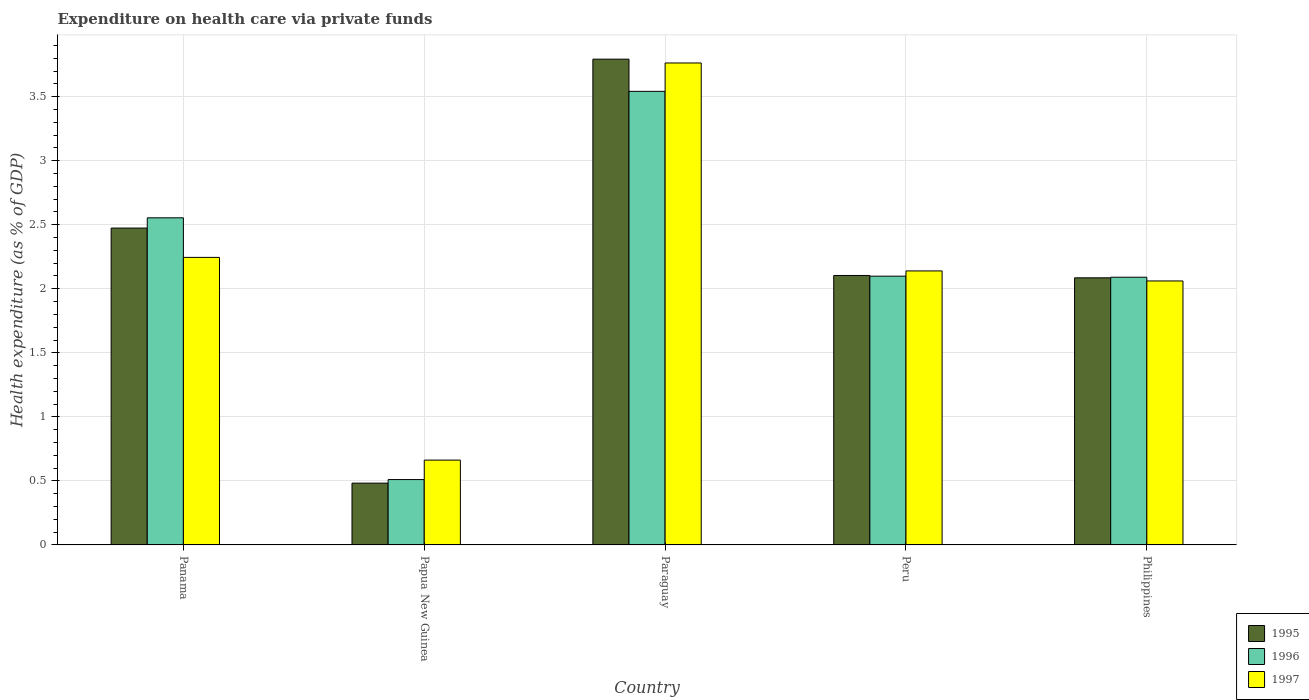How many different coloured bars are there?
Keep it short and to the point. 3. Are the number of bars per tick equal to the number of legend labels?
Offer a terse response. Yes. In how many cases, is the number of bars for a given country not equal to the number of legend labels?
Give a very brief answer. 0. What is the expenditure made on health care in 1996 in Paraguay?
Your answer should be very brief. 3.54. Across all countries, what is the maximum expenditure made on health care in 1996?
Offer a terse response. 3.54. Across all countries, what is the minimum expenditure made on health care in 1996?
Your answer should be compact. 0.51. In which country was the expenditure made on health care in 1996 maximum?
Your response must be concise. Paraguay. In which country was the expenditure made on health care in 1995 minimum?
Offer a very short reply. Papua New Guinea. What is the total expenditure made on health care in 1996 in the graph?
Your answer should be compact. 10.8. What is the difference between the expenditure made on health care in 1996 in Paraguay and that in Peru?
Your answer should be very brief. 1.44. What is the difference between the expenditure made on health care in 1997 in Peru and the expenditure made on health care in 1995 in Panama?
Your answer should be very brief. -0.33. What is the average expenditure made on health care in 1996 per country?
Provide a short and direct response. 2.16. What is the difference between the expenditure made on health care of/in 1996 and expenditure made on health care of/in 1995 in Paraguay?
Provide a short and direct response. -0.25. In how many countries, is the expenditure made on health care in 1996 greater than 3.6 %?
Offer a terse response. 0. What is the ratio of the expenditure made on health care in 1997 in Paraguay to that in Philippines?
Your answer should be compact. 1.83. Is the expenditure made on health care in 1997 in Paraguay less than that in Philippines?
Offer a terse response. No. What is the difference between the highest and the second highest expenditure made on health care in 1996?
Give a very brief answer. -0.99. What is the difference between the highest and the lowest expenditure made on health care in 1996?
Ensure brevity in your answer.  3.03. In how many countries, is the expenditure made on health care in 1997 greater than the average expenditure made on health care in 1997 taken over all countries?
Provide a succinct answer. 2. What does the 3rd bar from the right in Paraguay represents?
Offer a terse response. 1995. How many bars are there?
Keep it short and to the point. 15. How many countries are there in the graph?
Offer a terse response. 5. Does the graph contain grids?
Provide a succinct answer. Yes. How many legend labels are there?
Keep it short and to the point. 3. How are the legend labels stacked?
Make the answer very short. Vertical. What is the title of the graph?
Provide a succinct answer. Expenditure on health care via private funds. What is the label or title of the X-axis?
Your answer should be very brief. Country. What is the label or title of the Y-axis?
Ensure brevity in your answer.  Health expenditure (as % of GDP). What is the Health expenditure (as % of GDP) of 1995 in Panama?
Keep it short and to the point. 2.47. What is the Health expenditure (as % of GDP) in 1996 in Panama?
Your answer should be very brief. 2.55. What is the Health expenditure (as % of GDP) in 1997 in Panama?
Give a very brief answer. 2.25. What is the Health expenditure (as % of GDP) of 1995 in Papua New Guinea?
Your answer should be compact. 0.48. What is the Health expenditure (as % of GDP) of 1996 in Papua New Guinea?
Give a very brief answer. 0.51. What is the Health expenditure (as % of GDP) in 1997 in Papua New Guinea?
Your response must be concise. 0.66. What is the Health expenditure (as % of GDP) in 1995 in Paraguay?
Your answer should be very brief. 3.79. What is the Health expenditure (as % of GDP) of 1996 in Paraguay?
Offer a very short reply. 3.54. What is the Health expenditure (as % of GDP) of 1997 in Paraguay?
Offer a very short reply. 3.76. What is the Health expenditure (as % of GDP) of 1995 in Peru?
Keep it short and to the point. 2.1. What is the Health expenditure (as % of GDP) of 1996 in Peru?
Your answer should be very brief. 2.1. What is the Health expenditure (as % of GDP) of 1997 in Peru?
Offer a terse response. 2.14. What is the Health expenditure (as % of GDP) of 1995 in Philippines?
Your answer should be compact. 2.09. What is the Health expenditure (as % of GDP) in 1996 in Philippines?
Provide a short and direct response. 2.09. What is the Health expenditure (as % of GDP) in 1997 in Philippines?
Offer a terse response. 2.06. Across all countries, what is the maximum Health expenditure (as % of GDP) in 1995?
Your answer should be very brief. 3.79. Across all countries, what is the maximum Health expenditure (as % of GDP) in 1996?
Your answer should be very brief. 3.54. Across all countries, what is the maximum Health expenditure (as % of GDP) of 1997?
Offer a very short reply. 3.76. Across all countries, what is the minimum Health expenditure (as % of GDP) in 1995?
Provide a succinct answer. 0.48. Across all countries, what is the minimum Health expenditure (as % of GDP) in 1996?
Keep it short and to the point. 0.51. Across all countries, what is the minimum Health expenditure (as % of GDP) of 1997?
Offer a terse response. 0.66. What is the total Health expenditure (as % of GDP) in 1995 in the graph?
Provide a succinct answer. 10.94. What is the total Health expenditure (as % of GDP) in 1996 in the graph?
Offer a terse response. 10.8. What is the total Health expenditure (as % of GDP) in 1997 in the graph?
Provide a succinct answer. 10.87. What is the difference between the Health expenditure (as % of GDP) in 1995 in Panama and that in Papua New Guinea?
Ensure brevity in your answer.  1.99. What is the difference between the Health expenditure (as % of GDP) of 1996 in Panama and that in Papua New Guinea?
Provide a short and direct response. 2.04. What is the difference between the Health expenditure (as % of GDP) of 1997 in Panama and that in Papua New Guinea?
Offer a terse response. 1.58. What is the difference between the Health expenditure (as % of GDP) of 1995 in Panama and that in Paraguay?
Make the answer very short. -1.32. What is the difference between the Health expenditure (as % of GDP) of 1996 in Panama and that in Paraguay?
Keep it short and to the point. -0.99. What is the difference between the Health expenditure (as % of GDP) of 1997 in Panama and that in Paraguay?
Make the answer very short. -1.52. What is the difference between the Health expenditure (as % of GDP) of 1995 in Panama and that in Peru?
Provide a succinct answer. 0.37. What is the difference between the Health expenditure (as % of GDP) in 1996 in Panama and that in Peru?
Ensure brevity in your answer.  0.46. What is the difference between the Health expenditure (as % of GDP) in 1997 in Panama and that in Peru?
Ensure brevity in your answer.  0.11. What is the difference between the Health expenditure (as % of GDP) of 1995 in Panama and that in Philippines?
Provide a short and direct response. 0.39. What is the difference between the Health expenditure (as % of GDP) in 1996 in Panama and that in Philippines?
Offer a terse response. 0.46. What is the difference between the Health expenditure (as % of GDP) of 1997 in Panama and that in Philippines?
Offer a very short reply. 0.18. What is the difference between the Health expenditure (as % of GDP) of 1995 in Papua New Guinea and that in Paraguay?
Offer a terse response. -3.31. What is the difference between the Health expenditure (as % of GDP) of 1996 in Papua New Guinea and that in Paraguay?
Ensure brevity in your answer.  -3.03. What is the difference between the Health expenditure (as % of GDP) in 1997 in Papua New Guinea and that in Paraguay?
Keep it short and to the point. -3.1. What is the difference between the Health expenditure (as % of GDP) of 1995 in Papua New Guinea and that in Peru?
Keep it short and to the point. -1.62. What is the difference between the Health expenditure (as % of GDP) in 1996 in Papua New Guinea and that in Peru?
Provide a succinct answer. -1.59. What is the difference between the Health expenditure (as % of GDP) of 1997 in Papua New Guinea and that in Peru?
Give a very brief answer. -1.48. What is the difference between the Health expenditure (as % of GDP) of 1995 in Papua New Guinea and that in Philippines?
Make the answer very short. -1.6. What is the difference between the Health expenditure (as % of GDP) of 1996 in Papua New Guinea and that in Philippines?
Provide a succinct answer. -1.58. What is the difference between the Health expenditure (as % of GDP) in 1997 in Papua New Guinea and that in Philippines?
Provide a succinct answer. -1.4. What is the difference between the Health expenditure (as % of GDP) in 1995 in Paraguay and that in Peru?
Ensure brevity in your answer.  1.69. What is the difference between the Health expenditure (as % of GDP) in 1996 in Paraguay and that in Peru?
Give a very brief answer. 1.44. What is the difference between the Health expenditure (as % of GDP) of 1997 in Paraguay and that in Peru?
Your answer should be very brief. 1.62. What is the difference between the Health expenditure (as % of GDP) in 1995 in Paraguay and that in Philippines?
Make the answer very short. 1.71. What is the difference between the Health expenditure (as % of GDP) in 1996 in Paraguay and that in Philippines?
Make the answer very short. 1.45. What is the difference between the Health expenditure (as % of GDP) in 1997 in Paraguay and that in Philippines?
Keep it short and to the point. 1.7. What is the difference between the Health expenditure (as % of GDP) of 1995 in Peru and that in Philippines?
Keep it short and to the point. 0.02. What is the difference between the Health expenditure (as % of GDP) in 1996 in Peru and that in Philippines?
Provide a succinct answer. 0.01. What is the difference between the Health expenditure (as % of GDP) in 1997 in Peru and that in Philippines?
Offer a terse response. 0.08. What is the difference between the Health expenditure (as % of GDP) of 1995 in Panama and the Health expenditure (as % of GDP) of 1996 in Papua New Guinea?
Ensure brevity in your answer.  1.96. What is the difference between the Health expenditure (as % of GDP) in 1995 in Panama and the Health expenditure (as % of GDP) in 1997 in Papua New Guinea?
Offer a terse response. 1.81. What is the difference between the Health expenditure (as % of GDP) of 1996 in Panama and the Health expenditure (as % of GDP) of 1997 in Papua New Guinea?
Your answer should be compact. 1.89. What is the difference between the Health expenditure (as % of GDP) of 1995 in Panama and the Health expenditure (as % of GDP) of 1996 in Paraguay?
Give a very brief answer. -1.07. What is the difference between the Health expenditure (as % of GDP) in 1995 in Panama and the Health expenditure (as % of GDP) in 1997 in Paraguay?
Give a very brief answer. -1.29. What is the difference between the Health expenditure (as % of GDP) of 1996 in Panama and the Health expenditure (as % of GDP) of 1997 in Paraguay?
Offer a very short reply. -1.21. What is the difference between the Health expenditure (as % of GDP) in 1995 in Panama and the Health expenditure (as % of GDP) in 1996 in Peru?
Keep it short and to the point. 0.38. What is the difference between the Health expenditure (as % of GDP) of 1995 in Panama and the Health expenditure (as % of GDP) of 1997 in Peru?
Your answer should be compact. 0.33. What is the difference between the Health expenditure (as % of GDP) in 1996 in Panama and the Health expenditure (as % of GDP) in 1997 in Peru?
Offer a terse response. 0.41. What is the difference between the Health expenditure (as % of GDP) in 1995 in Panama and the Health expenditure (as % of GDP) in 1996 in Philippines?
Keep it short and to the point. 0.38. What is the difference between the Health expenditure (as % of GDP) in 1995 in Panama and the Health expenditure (as % of GDP) in 1997 in Philippines?
Your answer should be compact. 0.41. What is the difference between the Health expenditure (as % of GDP) of 1996 in Panama and the Health expenditure (as % of GDP) of 1997 in Philippines?
Make the answer very short. 0.49. What is the difference between the Health expenditure (as % of GDP) of 1995 in Papua New Guinea and the Health expenditure (as % of GDP) of 1996 in Paraguay?
Provide a succinct answer. -3.06. What is the difference between the Health expenditure (as % of GDP) of 1995 in Papua New Guinea and the Health expenditure (as % of GDP) of 1997 in Paraguay?
Give a very brief answer. -3.28. What is the difference between the Health expenditure (as % of GDP) of 1996 in Papua New Guinea and the Health expenditure (as % of GDP) of 1997 in Paraguay?
Make the answer very short. -3.25. What is the difference between the Health expenditure (as % of GDP) of 1995 in Papua New Guinea and the Health expenditure (as % of GDP) of 1996 in Peru?
Provide a short and direct response. -1.62. What is the difference between the Health expenditure (as % of GDP) of 1995 in Papua New Guinea and the Health expenditure (as % of GDP) of 1997 in Peru?
Provide a succinct answer. -1.66. What is the difference between the Health expenditure (as % of GDP) of 1996 in Papua New Guinea and the Health expenditure (as % of GDP) of 1997 in Peru?
Offer a very short reply. -1.63. What is the difference between the Health expenditure (as % of GDP) of 1995 in Papua New Guinea and the Health expenditure (as % of GDP) of 1996 in Philippines?
Your answer should be compact. -1.61. What is the difference between the Health expenditure (as % of GDP) of 1995 in Papua New Guinea and the Health expenditure (as % of GDP) of 1997 in Philippines?
Provide a succinct answer. -1.58. What is the difference between the Health expenditure (as % of GDP) of 1996 in Papua New Guinea and the Health expenditure (as % of GDP) of 1997 in Philippines?
Give a very brief answer. -1.55. What is the difference between the Health expenditure (as % of GDP) in 1995 in Paraguay and the Health expenditure (as % of GDP) in 1996 in Peru?
Make the answer very short. 1.69. What is the difference between the Health expenditure (as % of GDP) of 1995 in Paraguay and the Health expenditure (as % of GDP) of 1997 in Peru?
Offer a very short reply. 1.65. What is the difference between the Health expenditure (as % of GDP) in 1996 in Paraguay and the Health expenditure (as % of GDP) in 1997 in Peru?
Provide a short and direct response. 1.4. What is the difference between the Health expenditure (as % of GDP) in 1995 in Paraguay and the Health expenditure (as % of GDP) in 1996 in Philippines?
Ensure brevity in your answer.  1.7. What is the difference between the Health expenditure (as % of GDP) in 1995 in Paraguay and the Health expenditure (as % of GDP) in 1997 in Philippines?
Offer a very short reply. 1.73. What is the difference between the Health expenditure (as % of GDP) of 1996 in Paraguay and the Health expenditure (as % of GDP) of 1997 in Philippines?
Keep it short and to the point. 1.48. What is the difference between the Health expenditure (as % of GDP) of 1995 in Peru and the Health expenditure (as % of GDP) of 1996 in Philippines?
Provide a short and direct response. 0.01. What is the difference between the Health expenditure (as % of GDP) of 1995 in Peru and the Health expenditure (as % of GDP) of 1997 in Philippines?
Your response must be concise. 0.04. What is the difference between the Health expenditure (as % of GDP) in 1996 in Peru and the Health expenditure (as % of GDP) in 1997 in Philippines?
Give a very brief answer. 0.04. What is the average Health expenditure (as % of GDP) of 1995 per country?
Offer a very short reply. 2.19. What is the average Health expenditure (as % of GDP) in 1996 per country?
Give a very brief answer. 2.16. What is the average Health expenditure (as % of GDP) of 1997 per country?
Provide a succinct answer. 2.17. What is the difference between the Health expenditure (as % of GDP) in 1995 and Health expenditure (as % of GDP) in 1996 in Panama?
Your answer should be compact. -0.08. What is the difference between the Health expenditure (as % of GDP) in 1995 and Health expenditure (as % of GDP) in 1997 in Panama?
Provide a succinct answer. 0.23. What is the difference between the Health expenditure (as % of GDP) in 1996 and Health expenditure (as % of GDP) in 1997 in Panama?
Give a very brief answer. 0.31. What is the difference between the Health expenditure (as % of GDP) in 1995 and Health expenditure (as % of GDP) in 1996 in Papua New Guinea?
Provide a succinct answer. -0.03. What is the difference between the Health expenditure (as % of GDP) in 1995 and Health expenditure (as % of GDP) in 1997 in Papua New Guinea?
Provide a succinct answer. -0.18. What is the difference between the Health expenditure (as % of GDP) in 1996 and Health expenditure (as % of GDP) in 1997 in Papua New Guinea?
Keep it short and to the point. -0.15. What is the difference between the Health expenditure (as % of GDP) in 1995 and Health expenditure (as % of GDP) in 1996 in Paraguay?
Make the answer very short. 0.25. What is the difference between the Health expenditure (as % of GDP) in 1995 and Health expenditure (as % of GDP) in 1997 in Paraguay?
Offer a very short reply. 0.03. What is the difference between the Health expenditure (as % of GDP) of 1996 and Health expenditure (as % of GDP) of 1997 in Paraguay?
Offer a very short reply. -0.22. What is the difference between the Health expenditure (as % of GDP) in 1995 and Health expenditure (as % of GDP) in 1996 in Peru?
Keep it short and to the point. 0.01. What is the difference between the Health expenditure (as % of GDP) of 1995 and Health expenditure (as % of GDP) of 1997 in Peru?
Your answer should be very brief. -0.04. What is the difference between the Health expenditure (as % of GDP) of 1996 and Health expenditure (as % of GDP) of 1997 in Peru?
Your answer should be very brief. -0.04. What is the difference between the Health expenditure (as % of GDP) of 1995 and Health expenditure (as % of GDP) of 1996 in Philippines?
Your answer should be compact. -0. What is the difference between the Health expenditure (as % of GDP) in 1995 and Health expenditure (as % of GDP) in 1997 in Philippines?
Ensure brevity in your answer.  0.02. What is the difference between the Health expenditure (as % of GDP) of 1996 and Health expenditure (as % of GDP) of 1997 in Philippines?
Your answer should be very brief. 0.03. What is the ratio of the Health expenditure (as % of GDP) of 1995 in Panama to that in Papua New Guinea?
Make the answer very short. 5.13. What is the ratio of the Health expenditure (as % of GDP) in 1996 in Panama to that in Papua New Guinea?
Ensure brevity in your answer.  5. What is the ratio of the Health expenditure (as % of GDP) in 1997 in Panama to that in Papua New Guinea?
Make the answer very short. 3.39. What is the ratio of the Health expenditure (as % of GDP) of 1995 in Panama to that in Paraguay?
Keep it short and to the point. 0.65. What is the ratio of the Health expenditure (as % of GDP) in 1996 in Panama to that in Paraguay?
Make the answer very short. 0.72. What is the ratio of the Health expenditure (as % of GDP) of 1997 in Panama to that in Paraguay?
Offer a terse response. 0.6. What is the ratio of the Health expenditure (as % of GDP) in 1995 in Panama to that in Peru?
Your answer should be very brief. 1.18. What is the ratio of the Health expenditure (as % of GDP) of 1996 in Panama to that in Peru?
Offer a very short reply. 1.22. What is the ratio of the Health expenditure (as % of GDP) in 1997 in Panama to that in Peru?
Give a very brief answer. 1.05. What is the ratio of the Health expenditure (as % of GDP) in 1995 in Panama to that in Philippines?
Offer a very short reply. 1.19. What is the ratio of the Health expenditure (as % of GDP) in 1996 in Panama to that in Philippines?
Give a very brief answer. 1.22. What is the ratio of the Health expenditure (as % of GDP) in 1997 in Panama to that in Philippines?
Provide a succinct answer. 1.09. What is the ratio of the Health expenditure (as % of GDP) in 1995 in Papua New Guinea to that in Paraguay?
Your response must be concise. 0.13. What is the ratio of the Health expenditure (as % of GDP) in 1996 in Papua New Guinea to that in Paraguay?
Ensure brevity in your answer.  0.14. What is the ratio of the Health expenditure (as % of GDP) of 1997 in Papua New Guinea to that in Paraguay?
Make the answer very short. 0.18. What is the ratio of the Health expenditure (as % of GDP) of 1995 in Papua New Guinea to that in Peru?
Your answer should be very brief. 0.23. What is the ratio of the Health expenditure (as % of GDP) in 1996 in Papua New Guinea to that in Peru?
Provide a short and direct response. 0.24. What is the ratio of the Health expenditure (as % of GDP) in 1997 in Papua New Guinea to that in Peru?
Give a very brief answer. 0.31. What is the ratio of the Health expenditure (as % of GDP) of 1995 in Papua New Guinea to that in Philippines?
Make the answer very short. 0.23. What is the ratio of the Health expenditure (as % of GDP) in 1996 in Papua New Guinea to that in Philippines?
Your answer should be very brief. 0.24. What is the ratio of the Health expenditure (as % of GDP) of 1997 in Papua New Guinea to that in Philippines?
Provide a succinct answer. 0.32. What is the ratio of the Health expenditure (as % of GDP) of 1995 in Paraguay to that in Peru?
Give a very brief answer. 1.8. What is the ratio of the Health expenditure (as % of GDP) of 1996 in Paraguay to that in Peru?
Give a very brief answer. 1.69. What is the ratio of the Health expenditure (as % of GDP) of 1997 in Paraguay to that in Peru?
Provide a succinct answer. 1.76. What is the ratio of the Health expenditure (as % of GDP) in 1995 in Paraguay to that in Philippines?
Ensure brevity in your answer.  1.82. What is the ratio of the Health expenditure (as % of GDP) of 1996 in Paraguay to that in Philippines?
Make the answer very short. 1.69. What is the ratio of the Health expenditure (as % of GDP) of 1997 in Paraguay to that in Philippines?
Provide a short and direct response. 1.83. What is the ratio of the Health expenditure (as % of GDP) in 1995 in Peru to that in Philippines?
Provide a succinct answer. 1.01. What is the ratio of the Health expenditure (as % of GDP) of 1996 in Peru to that in Philippines?
Provide a short and direct response. 1. What is the ratio of the Health expenditure (as % of GDP) of 1997 in Peru to that in Philippines?
Provide a succinct answer. 1.04. What is the difference between the highest and the second highest Health expenditure (as % of GDP) in 1995?
Offer a very short reply. 1.32. What is the difference between the highest and the second highest Health expenditure (as % of GDP) of 1996?
Ensure brevity in your answer.  0.99. What is the difference between the highest and the second highest Health expenditure (as % of GDP) of 1997?
Ensure brevity in your answer.  1.52. What is the difference between the highest and the lowest Health expenditure (as % of GDP) in 1995?
Ensure brevity in your answer.  3.31. What is the difference between the highest and the lowest Health expenditure (as % of GDP) in 1996?
Ensure brevity in your answer.  3.03. What is the difference between the highest and the lowest Health expenditure (as % of GDP) in 1997?
Make the answer very short. 3.1. 